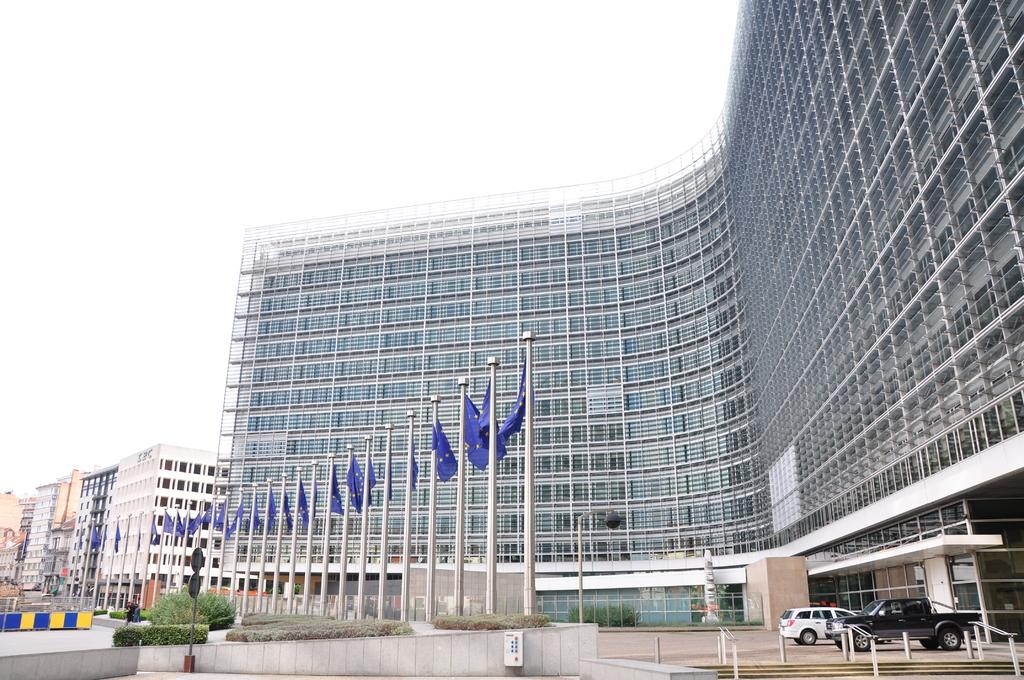What can be seen flying or waving in the image? There are flags in the image. What type of vegetation is present in the image? There are bushes and plants in the image. What type of animals are in the image? There are cats in the image. What architectural feature is present in the image? There are stairs in the image. What type of structures are present in the image? There are buildings in the image. What other objects can be seen in the image? There are poles, boards, and a bowl of ice cream in the image. What is visible at the top of the image? The sky is visible at the top of the image. What type of dress is the stamp wearing in the image? There is no stamp or dress present in the image. How does the help arrive in the image? There is no help or indication of assistance required in the image. 